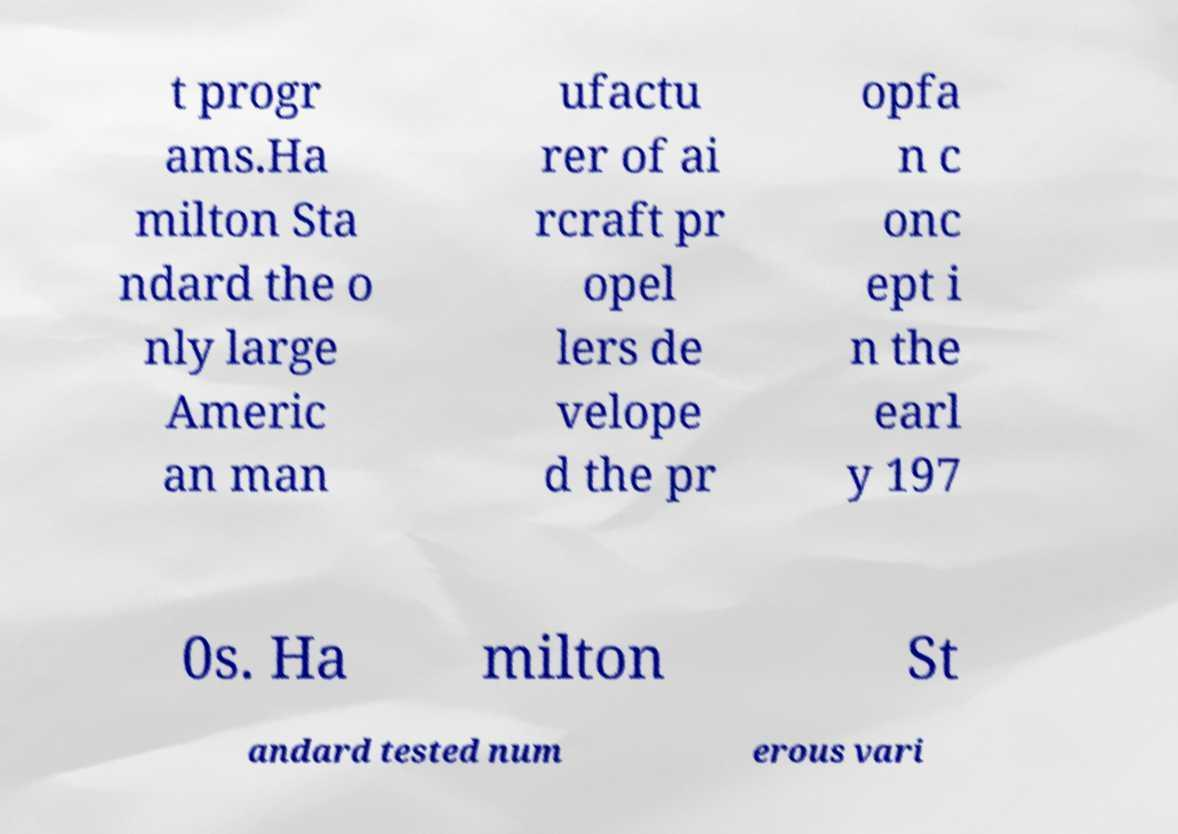Can you read and provide the text displayed in the image?This photo seems to have some interesting text. Can you extract and type it out for me? t progr ams.Ha milton Sta ndard the o nly large Americ an man ufactu rer of ai rcraft pr opel lers de velope d the pr opfa n c onc ept i n the earl y 197 0s. Ha milton St andard tested num erous vari 